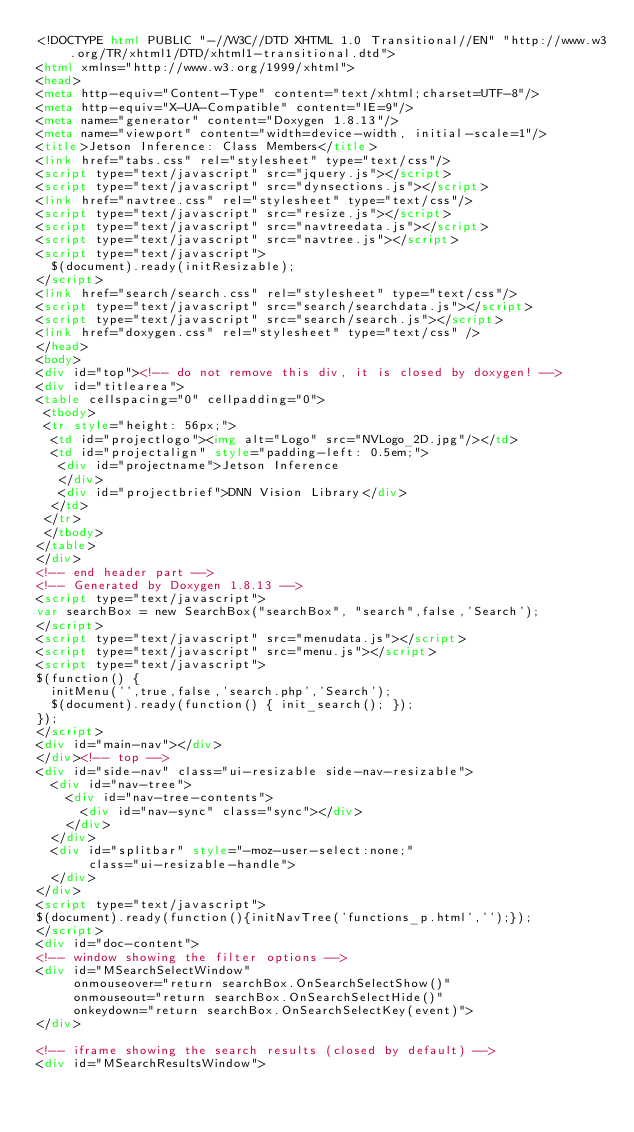<code> <loc_0><loc_0><loc_500><loc_500><_HTML_><!DOCTYPE html PUBLIC "-//W3C//DTD XHTML 1.0 Transitional//EN" "http://www.w3.org/TR/xhtml1/DTD/xhtml1-transitional.dtd">
<html xmlns="http://www.w3.org/1999/xhtml">
<head>
<meta http-equiv="Content-Type" content="text/xhtml;charset=UTF-8"/>
<meta http-equiv="X-UA-Compatible" content="IE=9"/>
<meta name="generator" content="Doxygen 1.8.13"/>
<meta name="viewport" content="width=device-width, initial-scale=1"/>
<title>Jetson Inference: Class Members</title>
<link href="tabs.css" rel="stylesheet" type="text/css"/>
<script type="text/javascript" src="jquery.js"></script>
<script type="text/javascript" src="dynsections.js"></script>
<link href="navtree.css" rel="stylesheet" type="text/css"/>
<script type="text/javascript" src="resize.js"></script>
<script type="text/javascript" src="navtreedata.js"></script>
<script type="text/javascript" src="navtree.js"></script>
<script type="text/javascript">
  $(document).ready(initResizable);
</script>
<link href="search/search.css" rel="stylesheet" type="text/css"/>
<script type="text/javascript" src="search/searchdata.js"></script>
<script type="text/javascript" src="search/search.js"></script>
<link href="doxygen.css" rel="stylesheet" type="text/css" />
</head>
<body>
<div id="top"><!-- do not remove this div, it is closed by doxygen! -->
<div id="titlearea">
<table cellspacing="0" cellpadding="0">
 <tbody>
 <tr style="height: 56px;">
  <td id="projectlogo"><img alt="Logo" src="NVLogo_2D.jpg"/></td>
  <td id="projectalign" style="padding-left: 0.5em;">
   <div id="projectname">Jetson Inference
   </div>
   <div id="projectbrief">DNN Vision Library</div>
  </td>
 </tr>
 </tbody>
</table>
</div>
<!-- end header part -->
<!-- Generated by Doxygen 1.8.13 -->
<script type="text/javascript">
var searchBox = new SearchBox("searchBox", "search",false,'Search');
</script>
<script type="text/javascript" src="menudata.js"></script>
<script type="text/javascript" src="menu.js"></script>
<script type="text/javascript">
$(function() {
  initMenu('',true,false,'search.php','Search');
  $(document).ready(function() { init_search(); });
});
</script>
<div id="main-nav"></div>
</div><!-- top -->
<div id="side-nav" class="ui-resizable side-nav-resizable">
  <div id="nav-tree">
    <div id="nav-tree-contents">
      <div id="nav-sync" class="sync"></div>
    </div>
  </div>
  <div id="splitbar" style="-moz-user-select:none;" 
       class="ui-resizable-handle">
  </div>
</div>
<script type="text/javascript">
$(document).ready(function(){initNavTree('functions_p.html','');});
</script>
<div id="doc-content">
<!-- window showing the filter options -->
<div id="MSearchSelectWindow"
     onmouseover="return searchBox.OnSearchSelectShow()"
     onmouseout="return searchBox.OnSearchSelectHide()"
     onkeydown="return searchBox.OnSearchSelectKey(event)">
</div>

<!-- iframe showing the search results (closed by default) -->
<div id="MSearchResultsWindow"></code> 